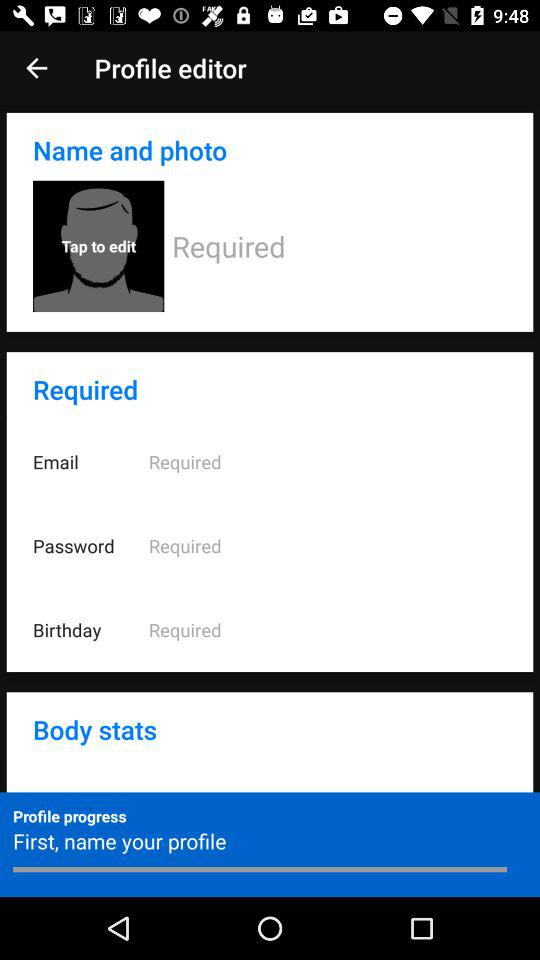What can be edited in the 'Name and photo' section of the profile editor? In the 'Name and photo' section, you can edit your display name and upload a profile picture. 